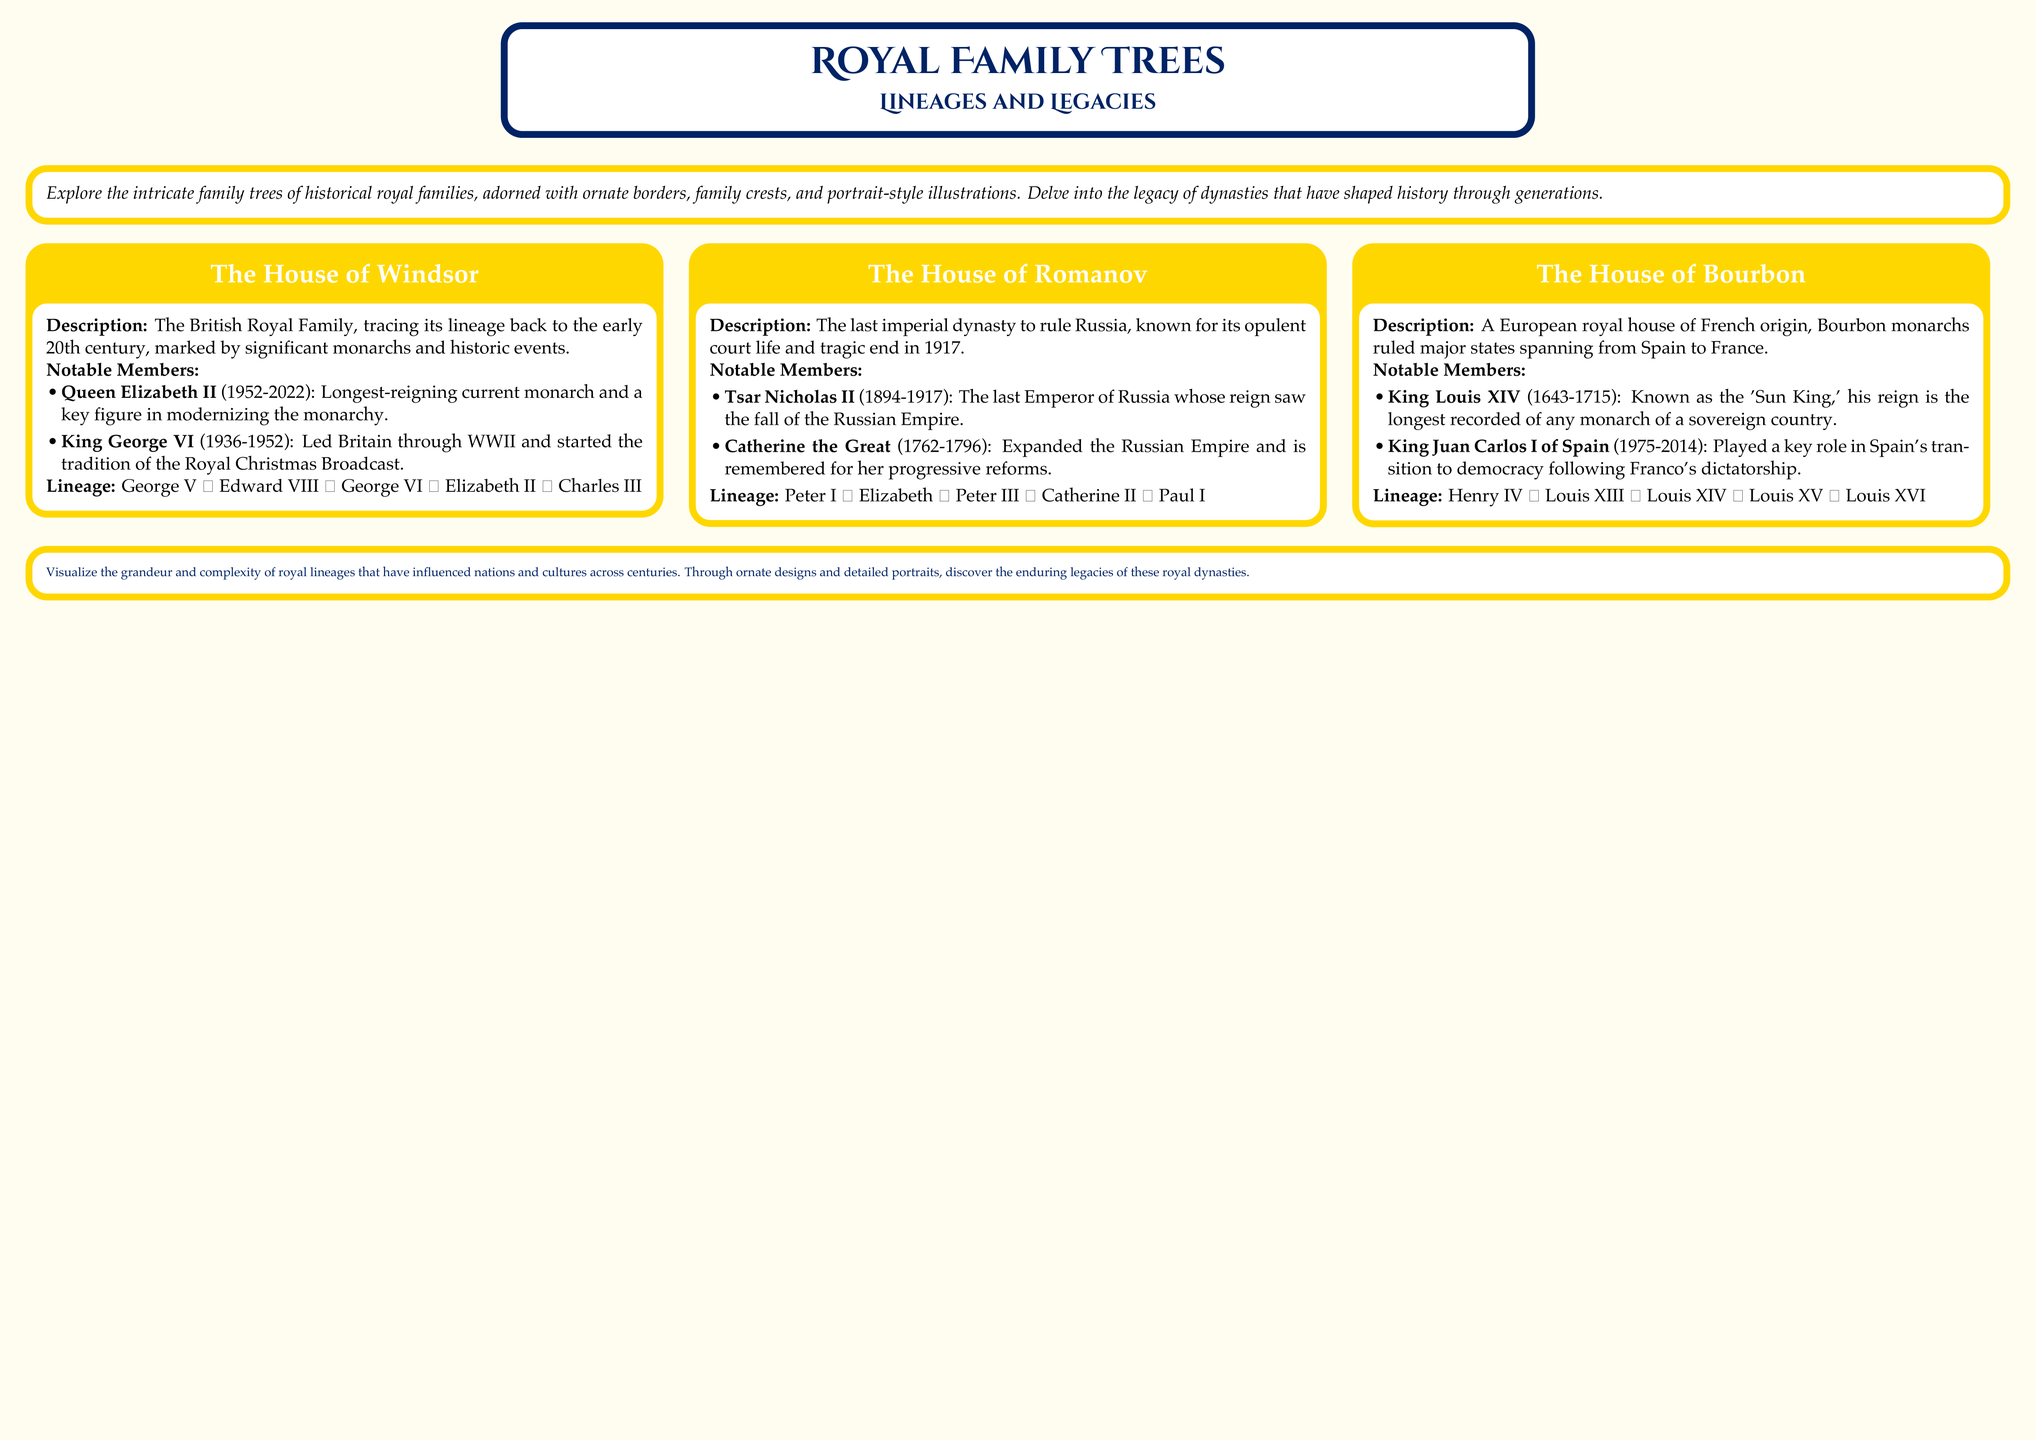what is the name of the longest-reigning monarch mentioned? The document states that Queen Elizabeth II is the longest-reigning current monarch.
Answer: Queen Elizabeth II who was the last Emperor of Russia? The family tree specifically mentions Tsar Nicholas II as the last Emperor of Russia.
Answer: Tsar Nicholas II which royal house is known for its tragic end in 1917? The document highlights the House of Romanov as the last imperial dynasty to rule Russia, which ended tragically in 1917.
Answer: House of Romanov how many generations are traced in the House of Windsor lineage? The lineage of the House of Windsor includes five members listed in the document.
Answer: Five name the monarch known as the 'Sun King.' The document mentions King Louis XIV by this title.
Answer: King Louis XIV who expanded the Russian Empire? Catherine the Great is noted for expanding the Russian Empire in the document.
Answer: Catherine the Great what color is used for the poster's background? The document specifies a creamy background color for the poster.
Answer: Creamy which royal house is associated with the longest reign? The House of Bourbon includes King Louis XIV, known for having the longest recorded reign.
Answer: House of Bourbon 